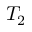Convert formula to latex. <formula><loc_0><loc_0><loc_500><loc_500>T _ { 2 }</formula> 